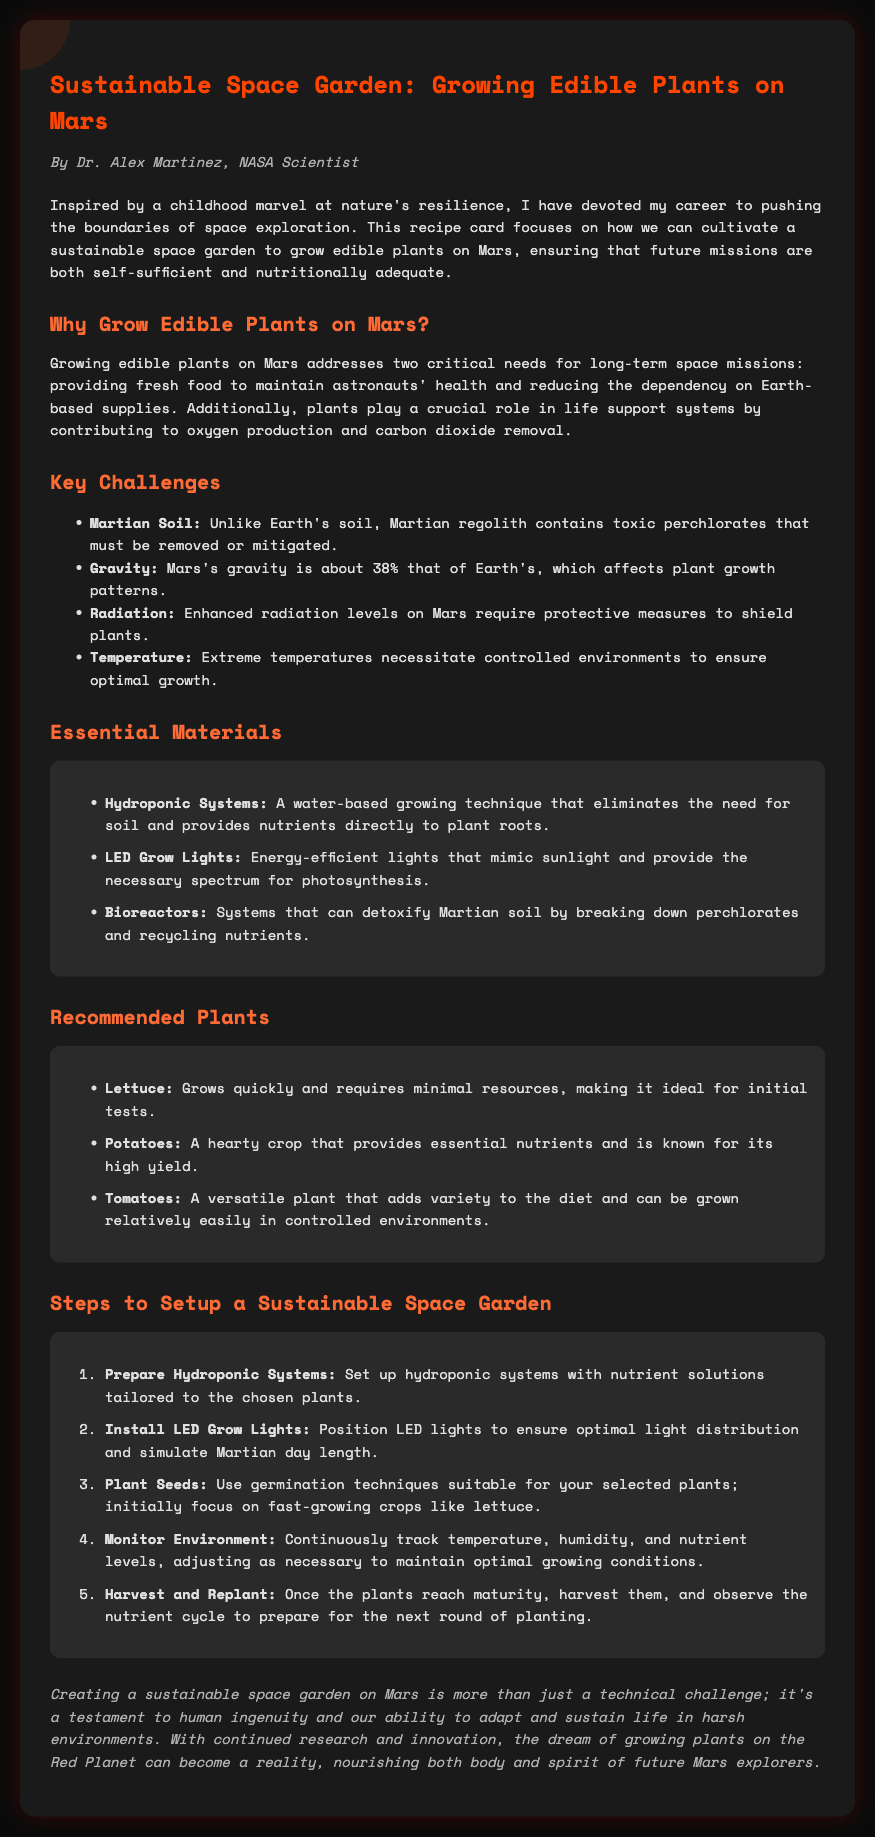What is the title of the document? The title is presented at the top of the document, which introduces the main subject matter regarding gardening on Mars.
Answer: Sustainable Space Garden: Growing Edible Plants on Mars Who is the author of the recipe card? The author is mentioned in the introduction, providing credibility to the information shared.
Answer: Dr. Alex Martinez What is a key challenge mentioned related to Martian soil? A specific challenge is highlighted regarding the toxicity of Martian regolith, which affects cultivation.
Answer: Toxic perchlorates Which hydroponic system material is listed as essential? The document explicitly identifies a water-based growing technique that is crucial for cultivating plants.
Answer: Hydroponic Systems Which plant is recommended for quick growth? One of the plants mentioned is known for its rapid growth and minimal resource needs.
Answer: Lettuce How many steps are listed for setting up the garden? The steps to establish a gardening system are enumerated in a sequential order.
Answer: Five steps What is the primary role of plants in life support systems on Mars? The document states the critical functions that plants serve for maintaining a livable environment.
Answer: Oxygen production What type of lights are specified for the garden? The type of lighting used to simulate sunlight and provide necessary wavelengths for plant growth is detailed.
Answer: LED Grow Lights What is the final objective of the sustainable space garden project? The conclusion summarizes the ultimate goal of this initiative for future Mars explorations.
Answer: Nourishing both body and spirit 